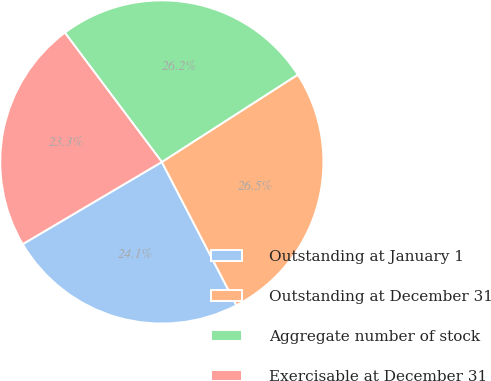Convert chart to OTSL. <chart><loc_0><loc_0><loc_500><loc_500><pie_chart><fcel>Outstanding at January 1<fcel>Outstanding at December 31<fcel>Aggregate number of stock<fcel>Exercisable at December 31<nl><fcel>24.14%<fcel>26.45%<fcel>26.15%<fcel>23.25%<nl></chart> 